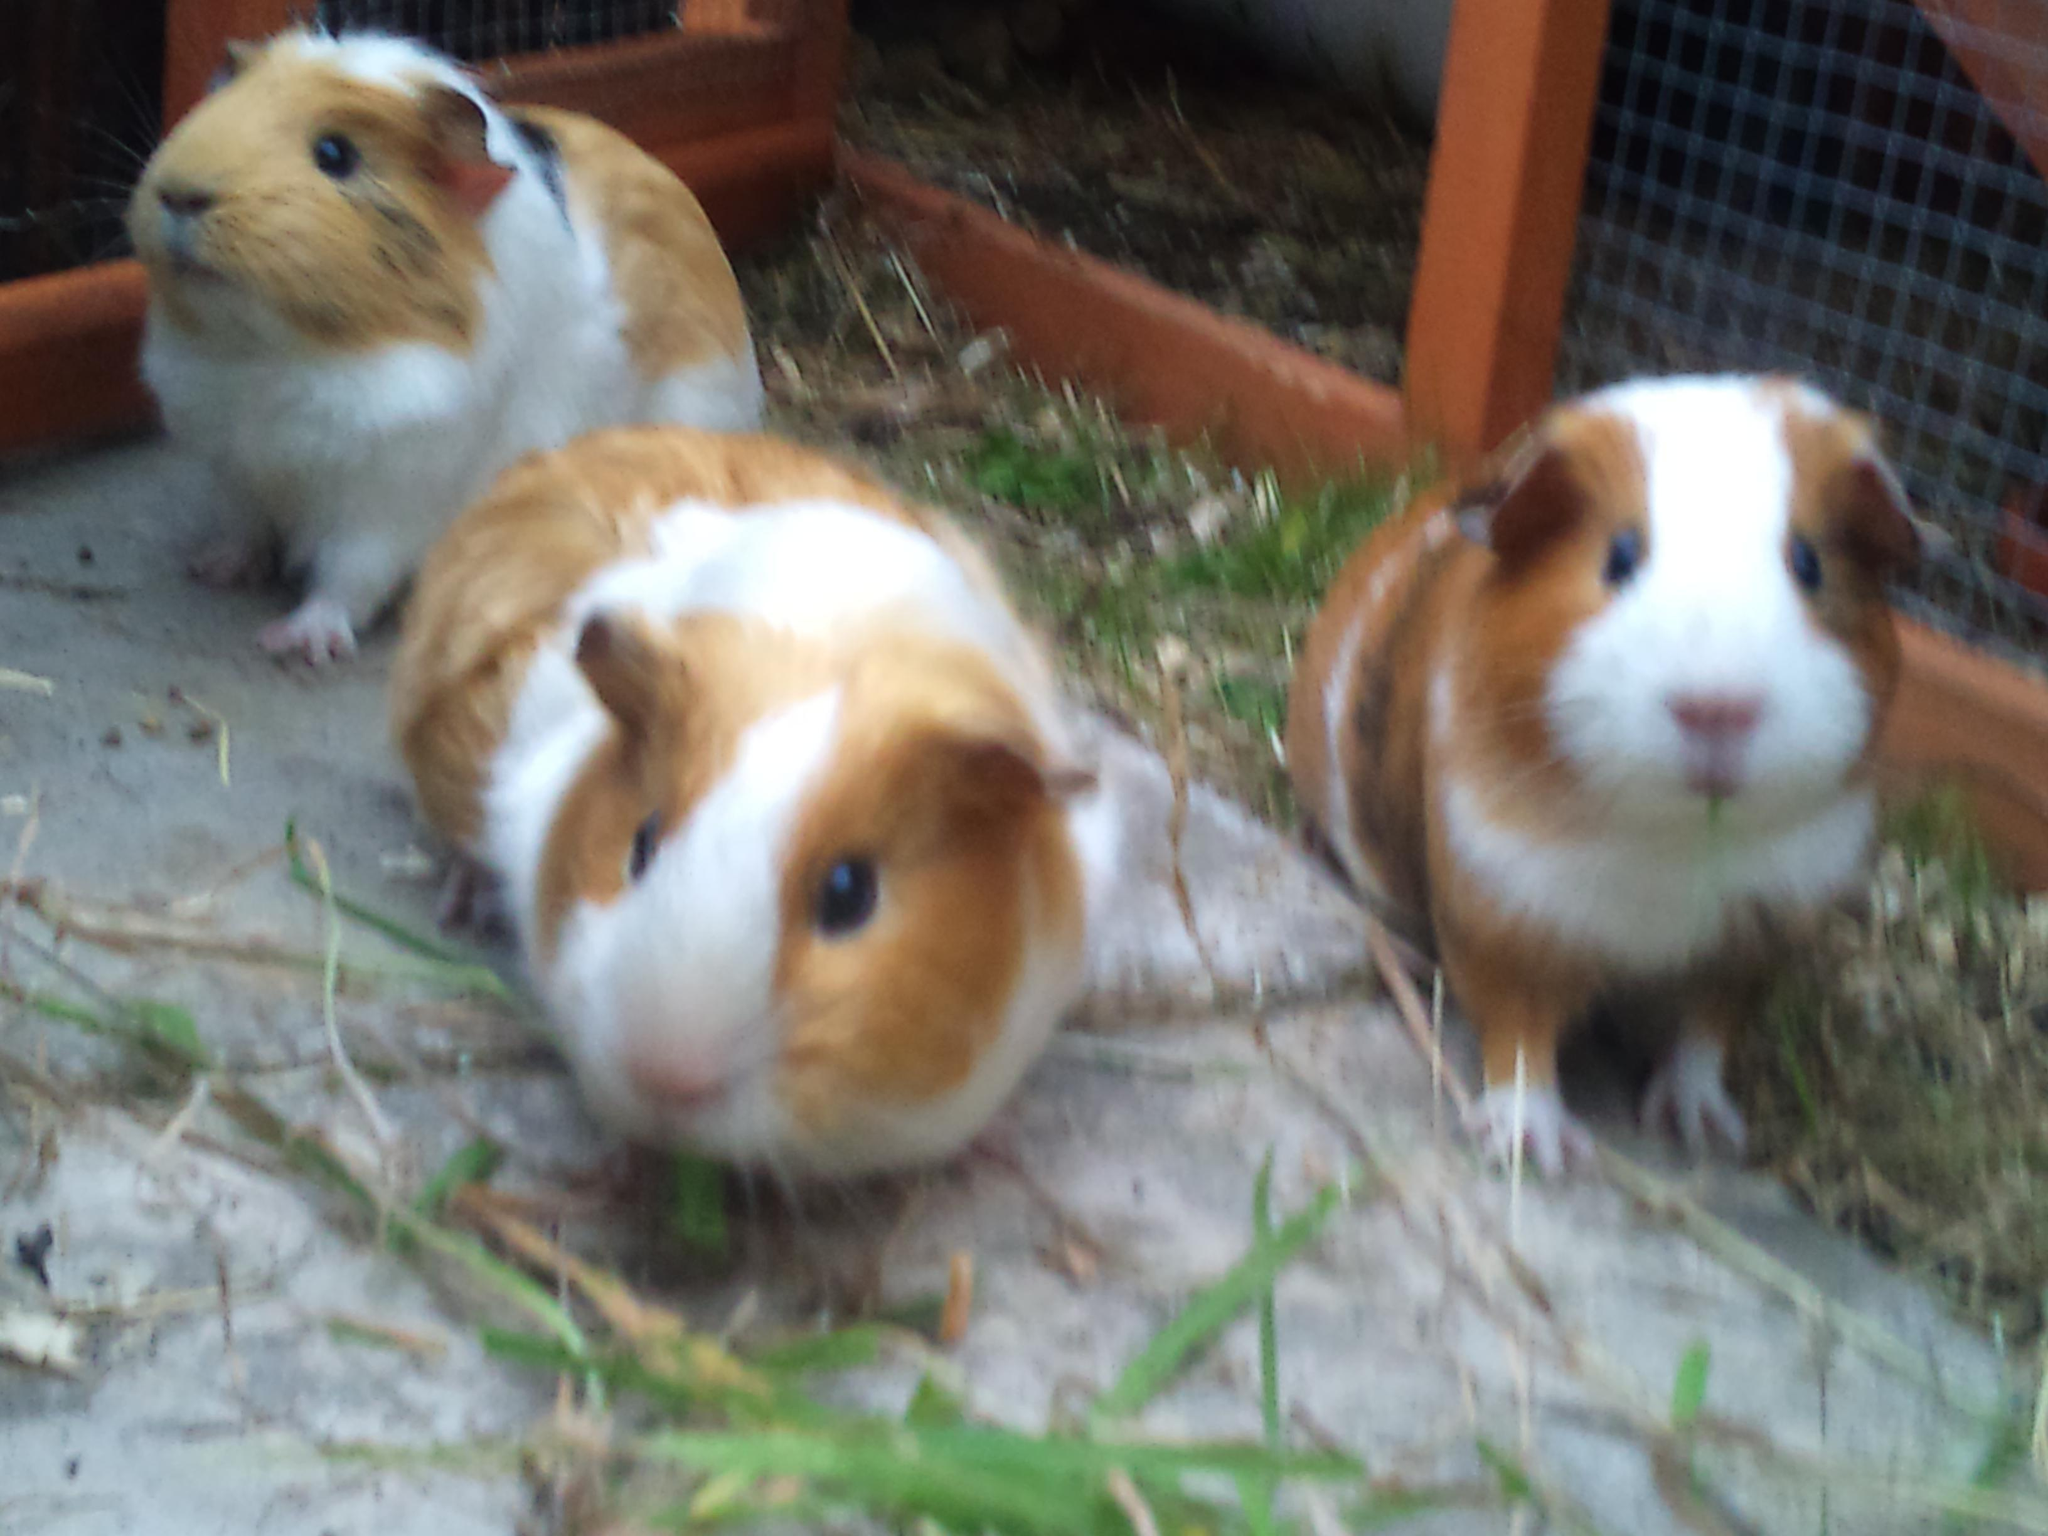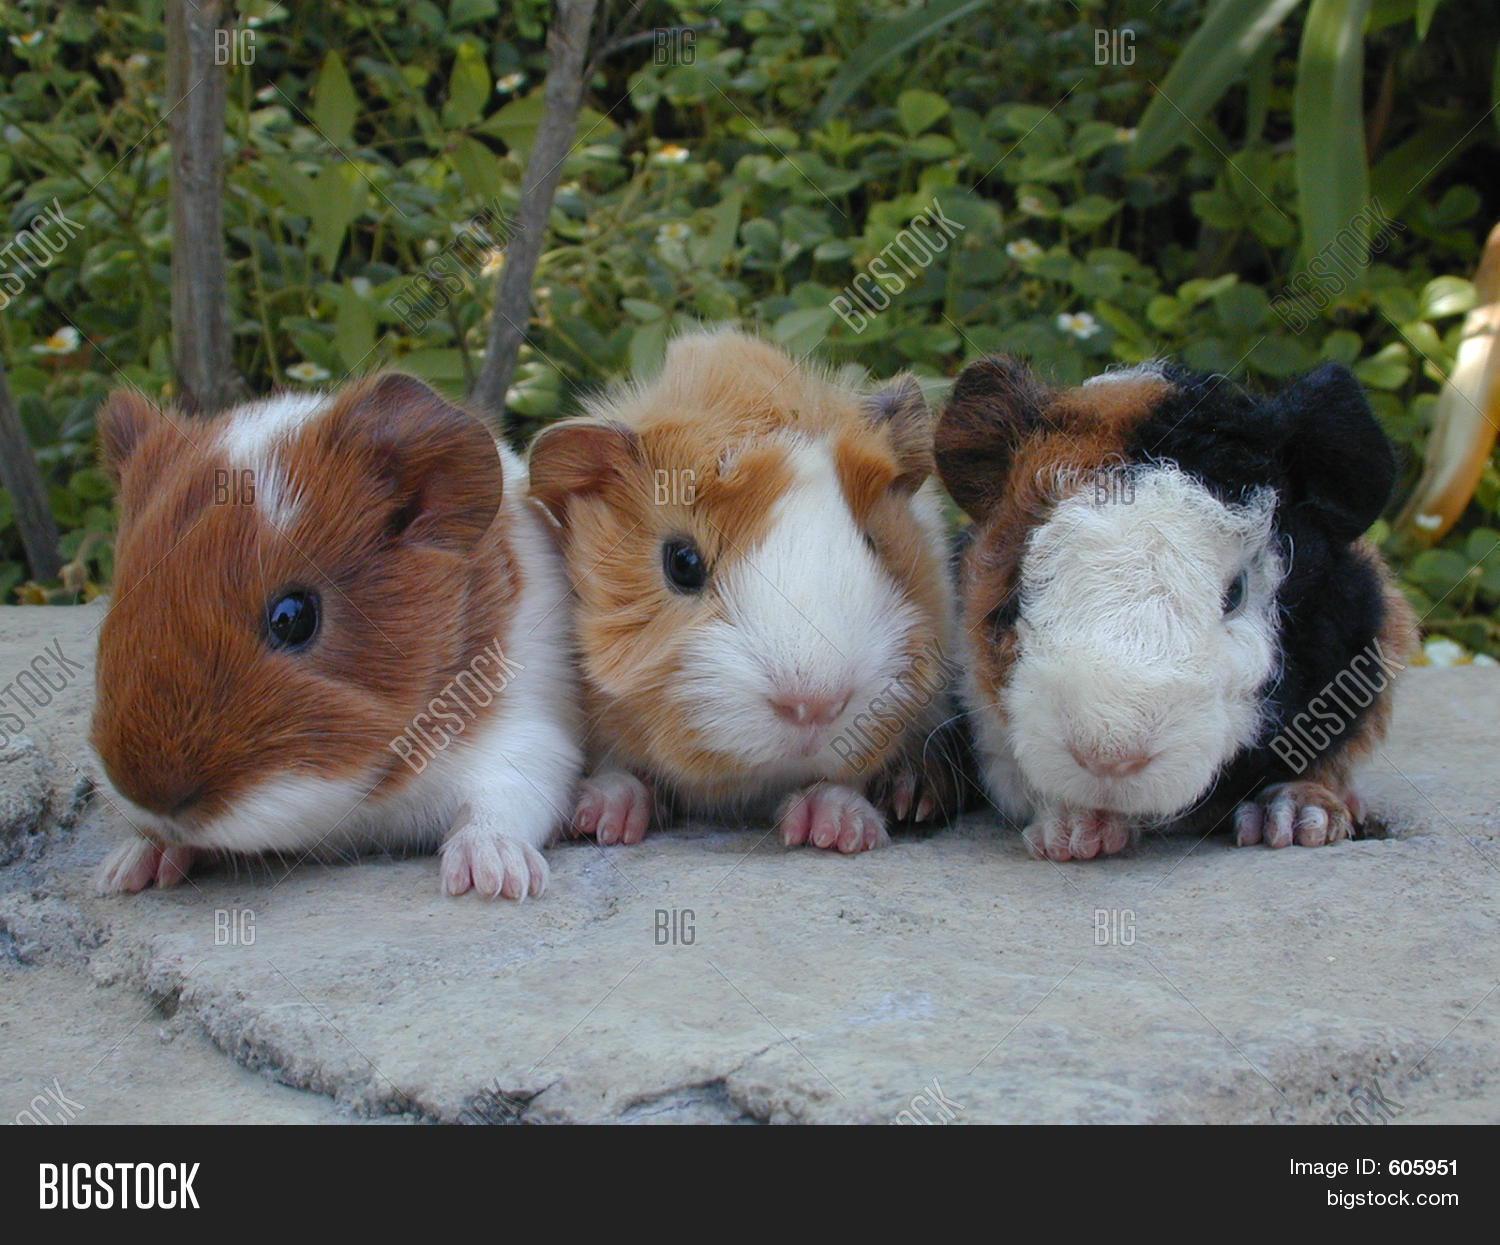The first image is the image on the left, the second image is the image on the right. Analyze the images presented: Is the assertion "There are 6 guinea pigs in all, the three in the image on the right are lined up side by side, looking at the camera." valid? Answer yes or no. Yes. The first image is the image on the left, the second image is the image on the right. Given the left and right images, does the statement "An image shows three multicolor guinea pigs posed side-by-side outdoors with greenery in the picture." hold true? Answer yes or no. Yes. 